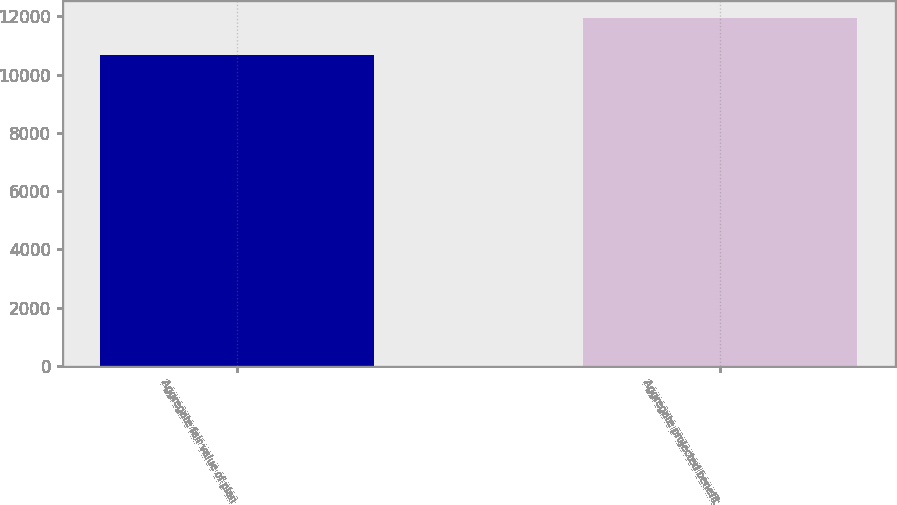Convert chart. <chart><loc_0><loc_0><loc_500><loc_500><bar_chart><fcel>Aggregate fair value of plan<fcel>Aggregate projected benefit<nl><fcel>10662<fcel>11945<nl></chart> 